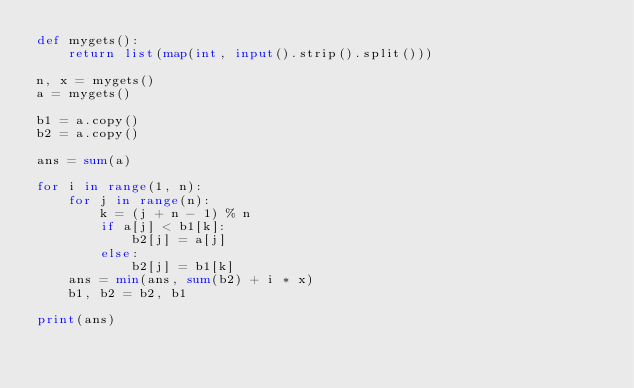<code> <loc_0><loc_0><loc_500><loc_500><_Python_>def mygets():
    return list(map(int, input().strip().split()))

n, x = mygets()
a = mygets()

b1 = a.copy()
b2 = a.copy()

ans = sum(a)

for i in range(1, n):
    for j in range(n):
        k = (j + n - 1) % n
        if a[j] < b1[k]:
            b2[j] = a[j]
        else:
            b2[j] = b1[k]
    ans = min(ans, sum(b2) + i * x)
    b1, b2 = b2, b1

print(ans)</code> 